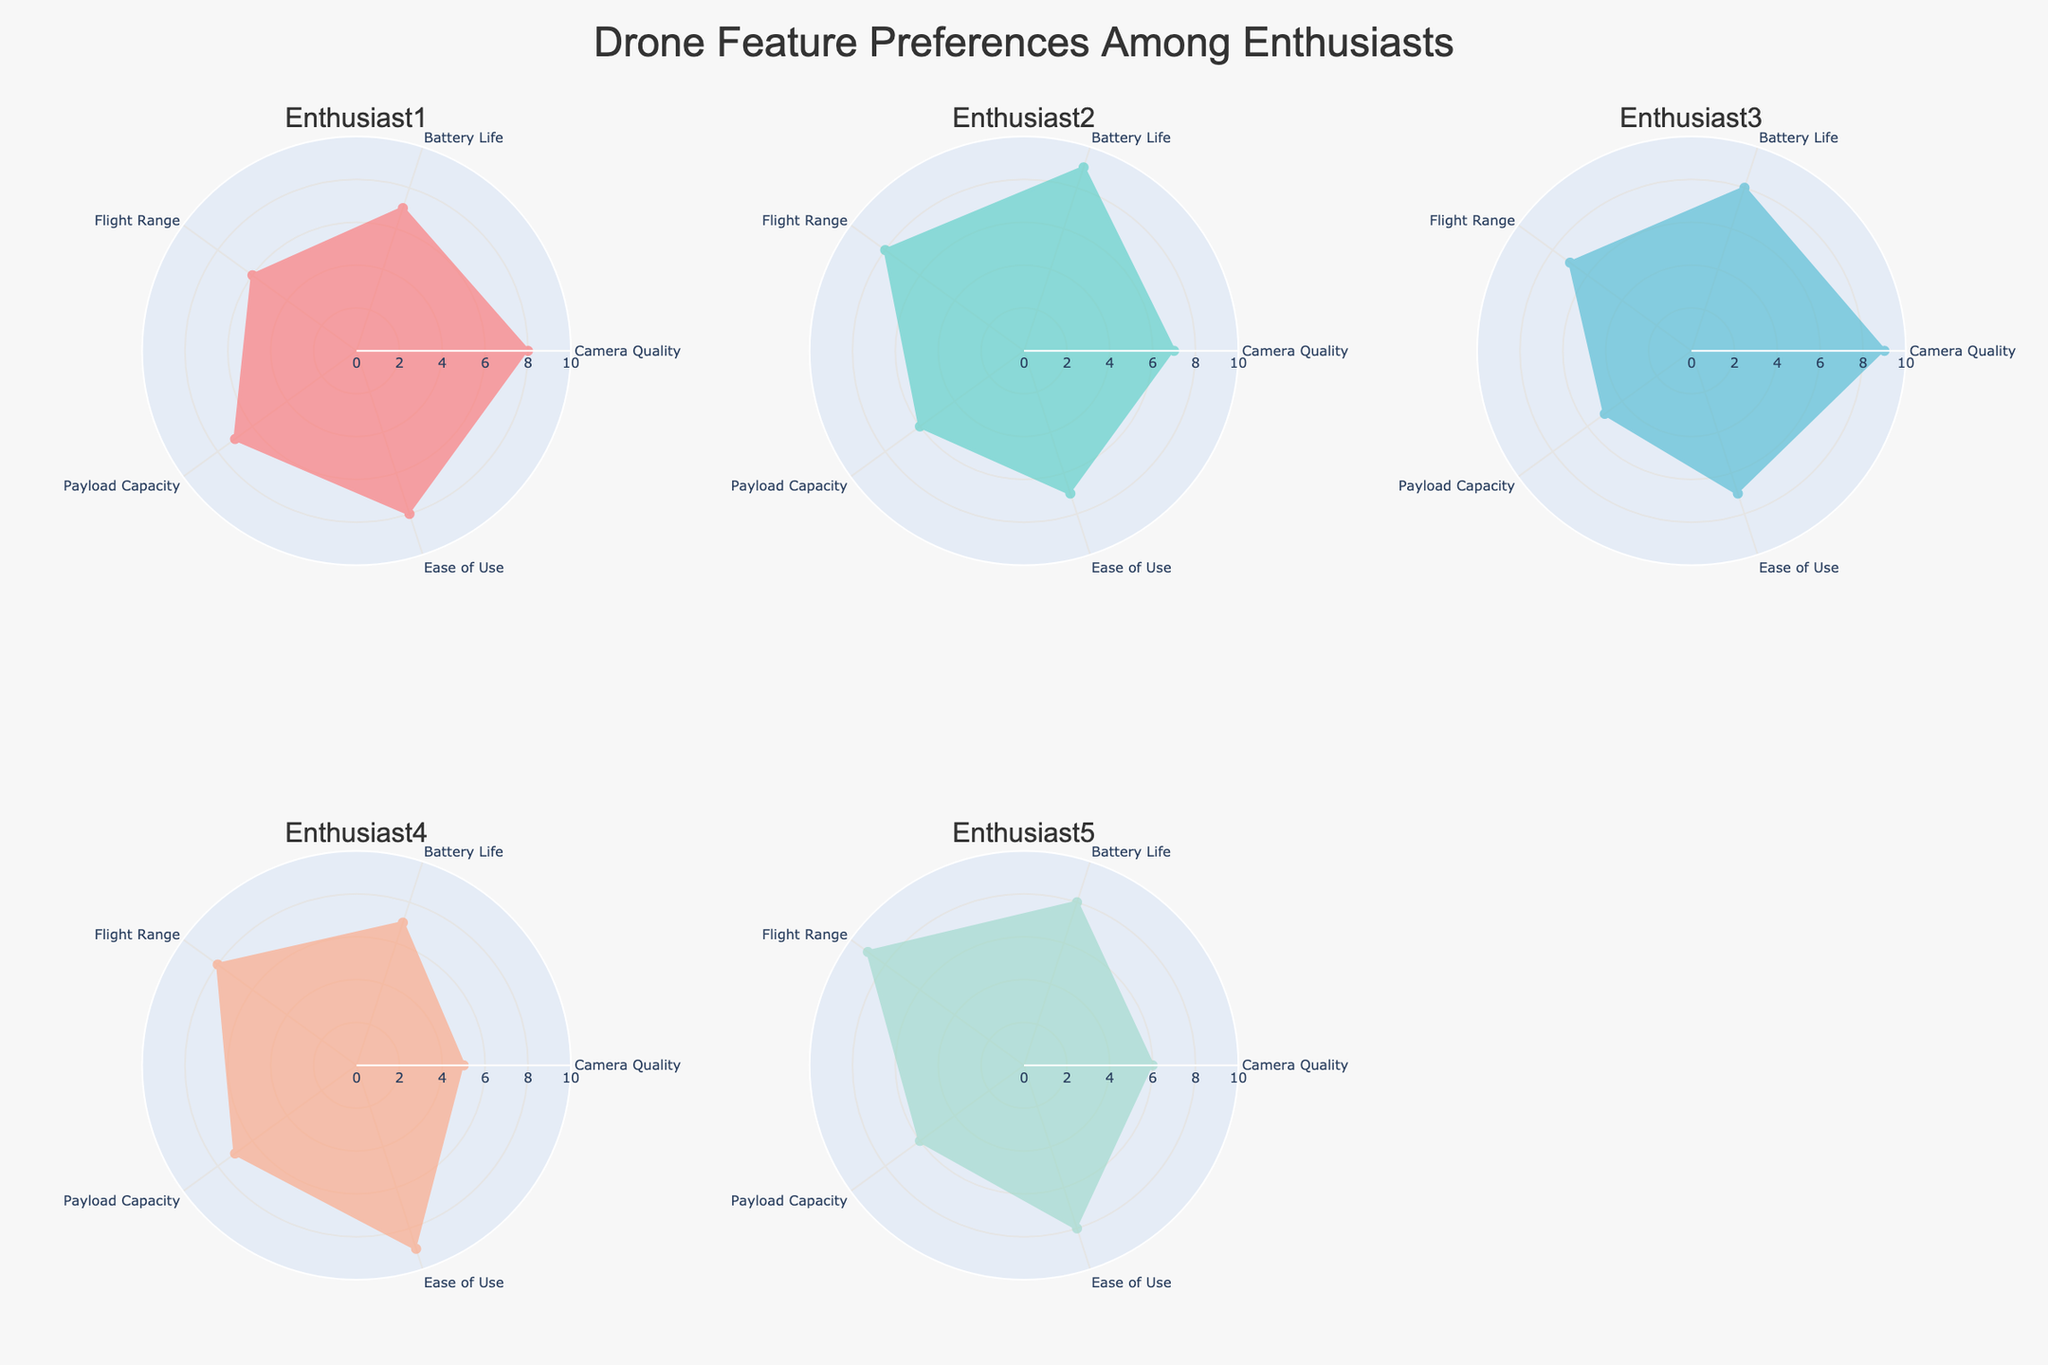What is the title of the figure? The title is located at the top center of the figure in a larger font size. It reads "Drone Feature Preferences Among Enthusiasts".
Answer: Drone Feature Preferences Among Enthusiasts Which enthusiast prefers Camera Quality the most? By observing the radial chart for each enthusiast, look for the one with the highest value for Camera Quality. Enthusiast 3 has a value of 9, which is the highest among all.
Answer: Enthusiast 3 What is the average rating for Battery Life across all enthusiasts? Sum the battery life ratings for all enthusiasts: 7 (Enthusiast 1) + 9 (Enthusiast 2) + 8 (Enthusiast 3) + 7 (Enthusiast 4) + 8 (Enthusiast 5) = 39. Then, divide by the number of enthusiasts: 39 / 5 = 7.8.
Answer: 7.8 Which enthusiast gives the highest rating for Ease of Use? Compare the Ease of Use values for each enthusiast. The highest value is 9, given by Enthusiast 4.
Answer: Enthusiast 4 Compare the preference for Payload Capacity between Enthusiast 1 and Enthusiast 3. Who prefers it more and by how much? Enthusiast 1 rates Payload Capacity at 7, and Enthusiast 3 rates it at 5. The difference is 7 - 5 = 2. Enthusiast 1 prefers it more by 2 units.
Answer: Enthusiast 1 by 2 What is the combined rating for Flight Range and Camera Quality for Enthusiast 2? For Enthusiast 2, add the Flight Range (8) and Camera Quality (7) ratings: 8 + 7 = 15.
Answer: 15 Which feature does Enthusiast 5 rate the highest? For Enthusiast 5, compare all the feature ratings. The highest rating is 9 for Flight Range.
Answer: Flight Range Is there any feature that all enthusiasts rate exactly the same? By checking each feature's ratings across enthusiasts, it’s evident that no feature has the same rating from all enthusiasts.
Answer: No Which two features have the closest average ratings across all enthusiasts? Calculate the average ratings for each feature: Camera Quality (7), Battery Life (7.8), Flight Range (7.6), Payload Capacity (6.2), Ease of Use (7.8). The closest averages are for Battery Life and Ease of Use, both at 7.8.
Answer: Battery Life and Ease of Use 